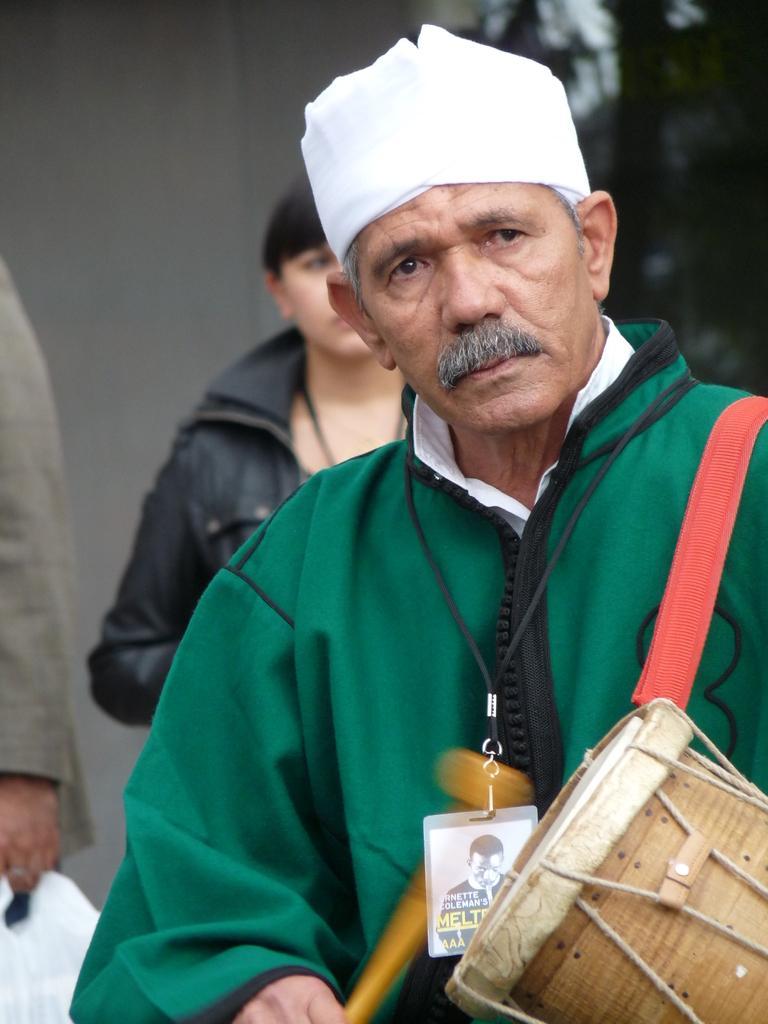How would you summarize this image in a sentence or two? In this image I can see a man and I can see he is wearing green colour dress and an ID card. I can also see he is holding a stick and carrying a musical instrument. In the background I can see few more people are standing and I can see this image is little bit blurry from background. 